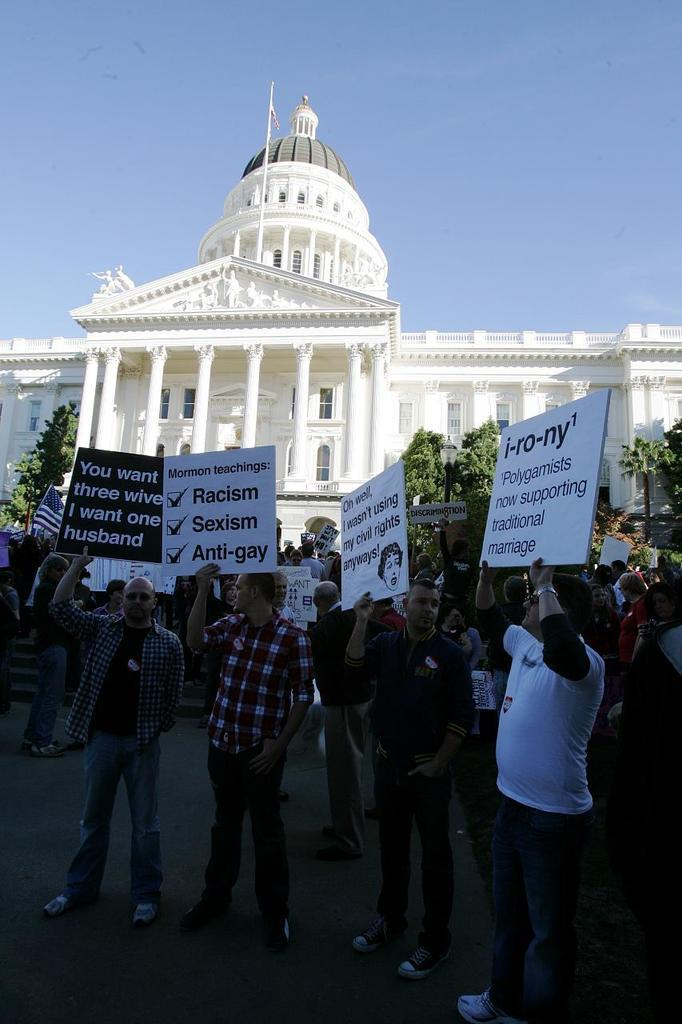What are the people in the image holding? The people in the image are holding placards with text. Where are the placards located in relation to the image? The placards are in the foreground of the image. What can be seen in the background of the image? There is a white color building in the background of the image. What is visible at the top of the image? The sky is visible at the top of the image. How many wounds can be seen on the people holding placards in the image? There are no visible wounds on the people holding placards in the image. Is there a rainstorm occurring in the image? There is no indication of a rainstorm in the image; the sky is visible at the top of the image. 